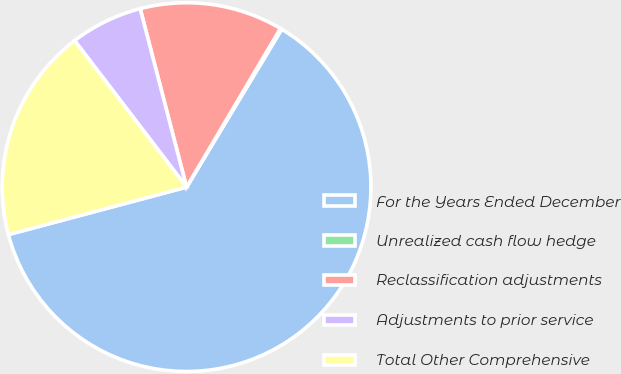<chart> <loc_0><loc_0><loc_500><loc_500><pie_chart><fcel>For the Years Ended December<fcel>Unrealized cash flow hedge<fcel>Reclassification adjustments<fcel>Adjustments to prior service<fcel>Total Other Comprehensive<nl><fcel>62.22%<fcel>0.13%<fcel>12.55%<fcel>6.34%<fcel>18.76%<nl></chart> 